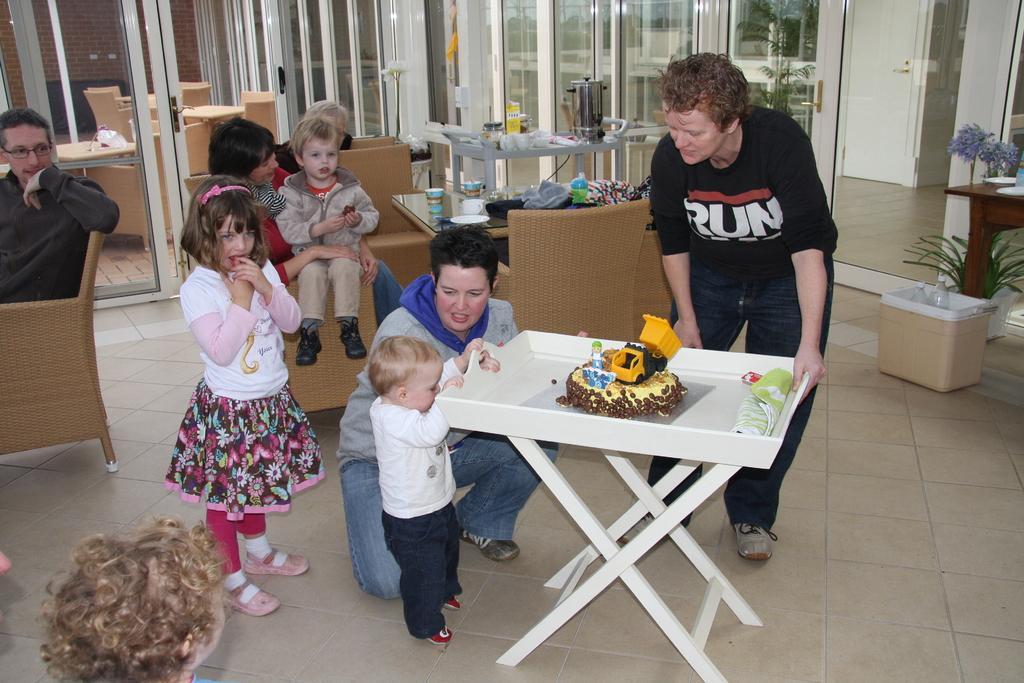Can you describe this image briefly? In this picture, we see many people are sitting on sofa and man in black t-shirt is standing. In front of them, we see a table on which cake and cloth are placed. Behind them, we see many tables and chair and on top of a picture, we see a glass door. On right bottom, right corner of the picture, we see a table on which plate and flower vase are placed. 